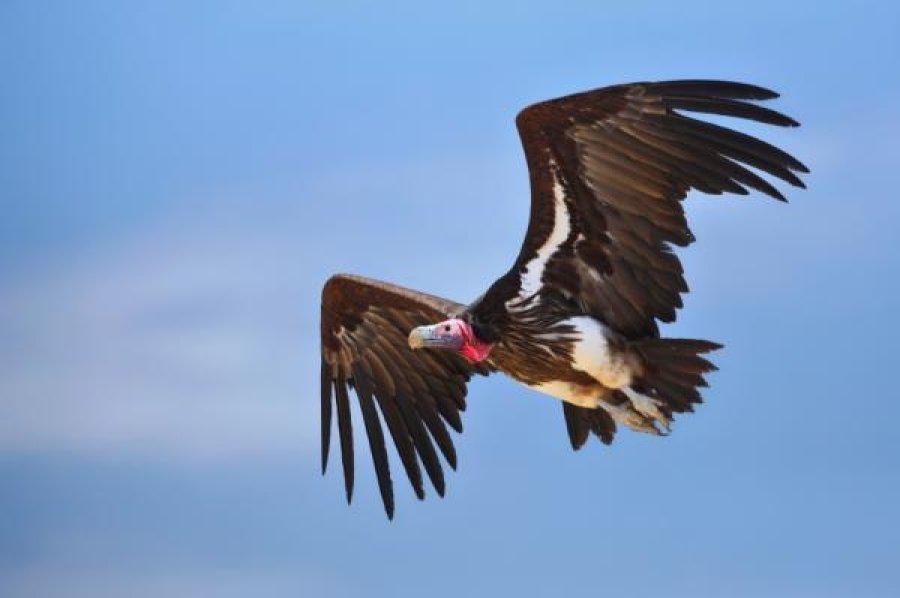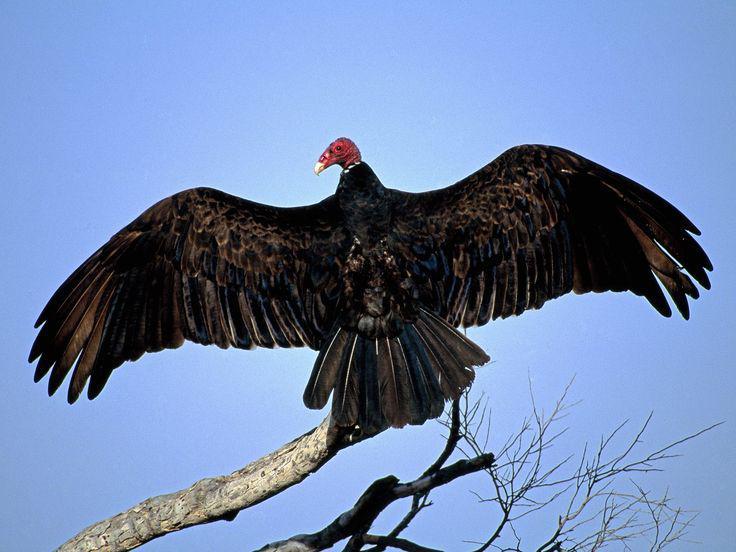The first image is the image on the left, the second image is the image on the right. Analyze the images presented: Is the assertion "A branch is visible only in the right image of a vulture." valid? Answer yes or no. Yes. 